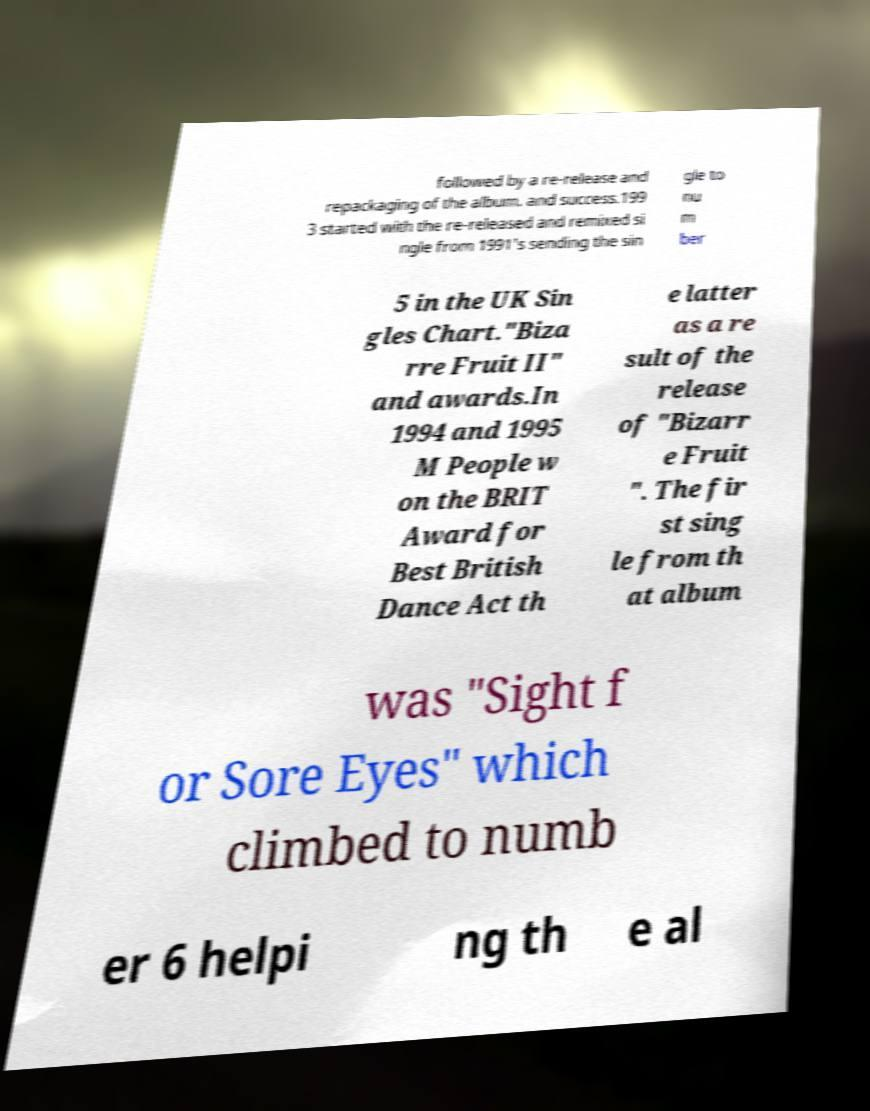What messages or text are displayed in this image? I need them in a readable, typed format. followed by a re-release and repackaging of the album. and success.199 3 started with the re-released and remixed si ngle from 1991's sending the sin gle to nu m ber 5 in the UK Sin gles Chart."Biza rre Fruit II" and awards.In 1994 and 1995 M People w on the BRIT Award for Best British Dance Act th e latter as a re sult of the release of "Bizarr e Fruit ". The fir st sing le from th at album was "Sight f or Sore Eyes" which climbed to numb er 6 helpi ng th e al 